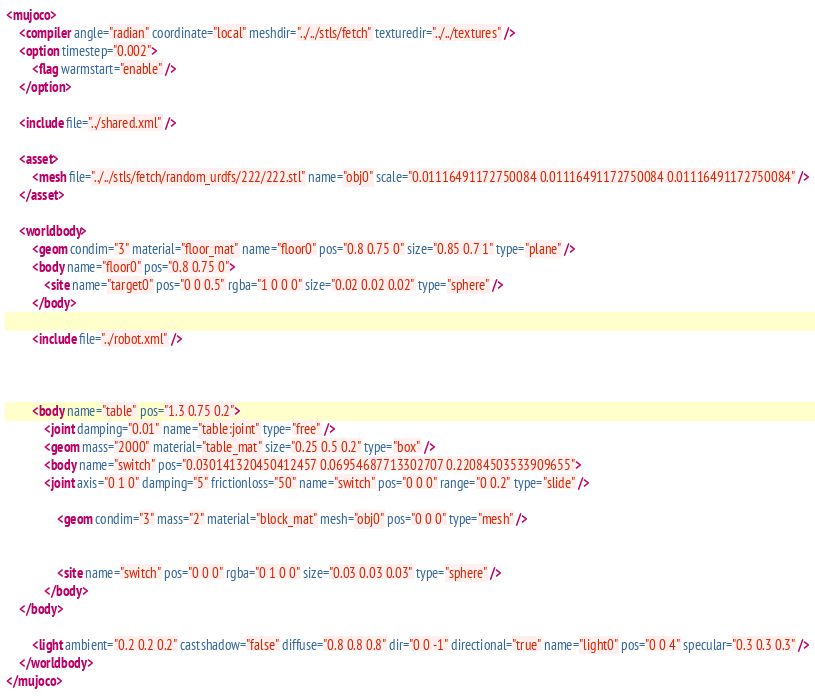Convert code to text. <code><loc_0><loc_0><loc_500><loc_500><_XML_><mujoco>
	<compiler angle="radian" coordinate="local" meshdir="../../stls/fetch" texturedir="../../textures" />
	<option timestep="0.002">
		<flag warmstart="enable" />
	</option>

	<include file="../shared.xml" />

	<asset>
		<mesh file="../../stls/fetch/random_urdfs/222/222.stl" name="obj0" scale="0.01116491172750084 0.01116491172750084 0.01116491172750084" />
	</asset>

	<worldbody>
		<geom condim="3" material="floor_mat" name="floor0" pos="0.8 0.75 0" size="0.85 0.7 1" type="plane" />
		<body name="floor0" pos="0.8 0.75 0">
			<site name="target0" pos="0 0 0.5" rgba="1 0 0 0" size="0.02 0.02 0.02" type="sphere" />
		</body>

		<include file="../robot.xml" />

		

		<body name="table" pos="1.3 0.75 0.2">
			<joint damping="0.01" name="table:joint" type="free" />
			<geom mass="2000" material="table_mat" size="0.25 0.5 0.2" type="box" />
			<body name="switch" pos="0.030141320450412457 0.06954687713302707 0.22084503533909655">
		    <joint axis="0 1 0" damping="5" frictionloss="50" name="switch" pos="0 0 0" range="0 0.2" type="slide" />
				
				<geom condim="3" mass="2" material="block_mat" mesh="obj0" pos="0 0 0" type="mesh" />
				
				
				<site name="switch" pos="0 0 0" rgba="0 1 0 0" size="0.03 0.03 0.03" type="sphere" />
			</body>
    </body>

		<light ambient="0.2 0.2 0.2" castshadow="false" diffuse="0.8 0.8 0.8" dir="0 0 -1" directional="true" name="light0" pos="0 0 4" specular="0.3 0.3 0.3" />
	</worldbody>
</mujoco></code> 